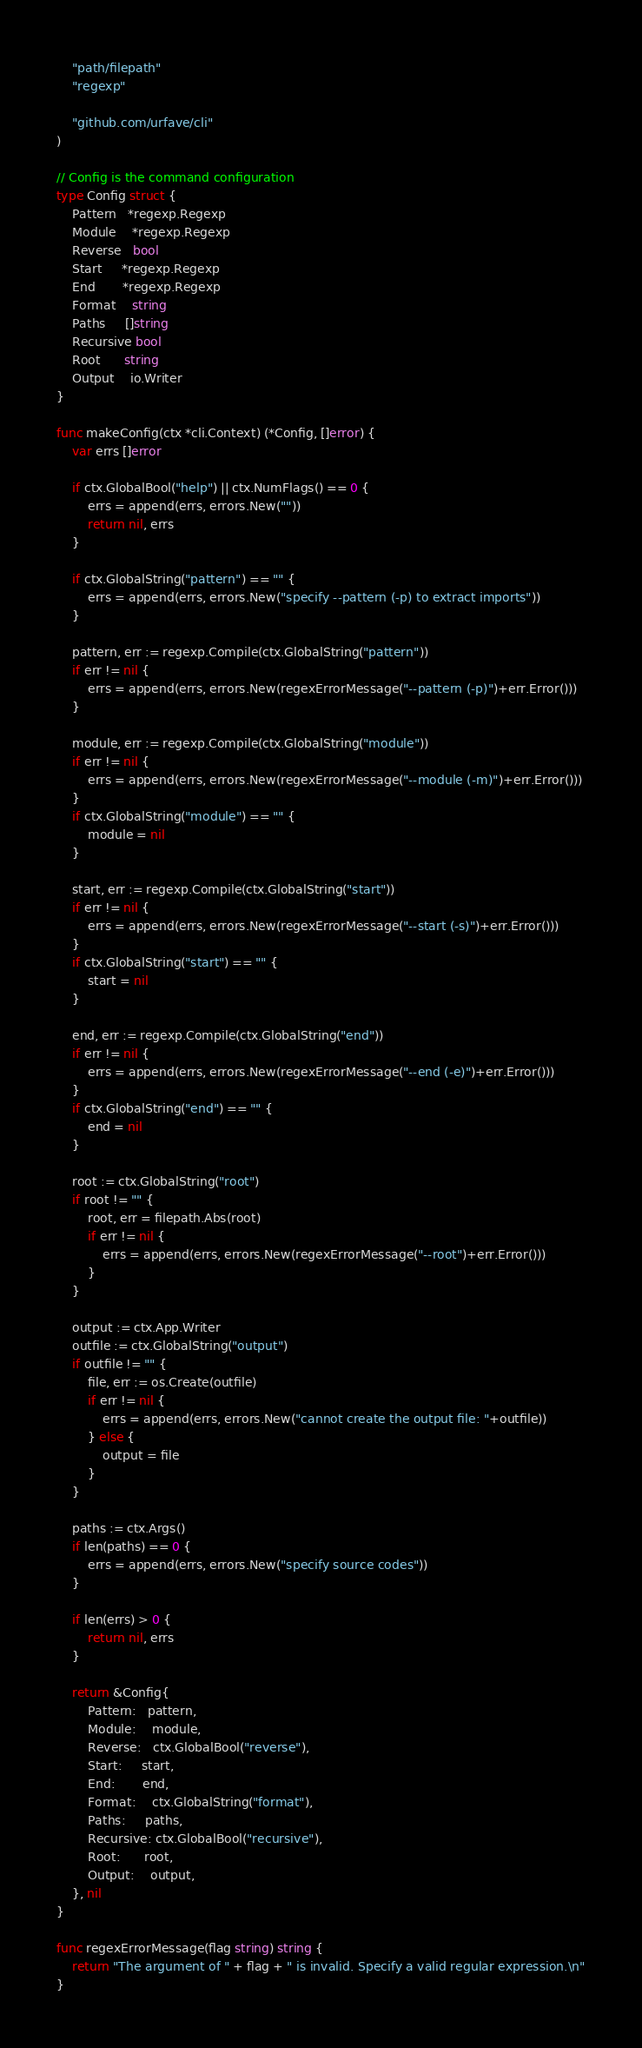<code> <loc_0><loc_0><loc_500><loc_500><_Go_>	"path/filepath"
	"regexp"

	"github.com/urfave/cli"
)

// Config is the command configuration
type Config struct {
	Pattern   *regexp.Regexp
	Module    *regexp.Regexp
	Reverse   bool
	Start     *regexp.Regexp
	End       *regexp.Regexp
	Format    string
	Paths     []string
	Recursive bool
	Root      string
	Output    io.Writer
}

func makeConfig(ctx *cli.Context) (*Config, []error) {
	var errs []error

	if ctx.GlobalBool("help") || ctx.NumFlags() == 0 {
		errs = append(errs, errors.New(""))
		return nil, errs
	}

	if ctx.GlobalString("pattern") == "" {
		errs = append(errs, errors.New("specify --pattern (-p) to extract imports"))
	}

	pattern, err := regexp.Compile(ctx.GlobalString("pattern"))
	if err != nil {
		errs = append(errs, errors.New(regexErrorMessage("--pattern (-p)")+err.Error()))
	}

	module, err := regexp.Compile(ctx.GlobalString("module"))
	if err != nil {
		errs = append(errs, errors.New(regexErrorMessage("--module (-m)")+err.Error()))
	}
	if ctx.GlobalString("module") == "" {
		module = nil
	}

	start, err := regexp.Compile(ctx.GlobalString("start"))
	if err != nil {
		errs = append(errs, errors.New(regexErrorMessage("--start (-s)")+err.Error()))
	}
	if ctx.GlobalString("start") == "" {
		start = nil
	}

	end, err := regexp.Compile(ctx.GlobalString("end"))
	if err != nil {
		errs = append(errs, errors.New(regexErrorMessage("--end (-e)")+err.Error()))
	}
	if ctx.GlobalString("end") == "" {
		end = nil
	}

	root := ctx.GlobalString("root")
	if root != "" {
		root, err = filepath.Abs(root)
		if err != nil {
			errs = append(errs, errors.New(regexErrorMessage("--root")+err.Error()))
		}
	}

	output := ctx.App.Writer
	outfile := ctx.GlobalString("output")
	if outfile != "" {
		file, err := os.Create(outfile)
		if err != nil {
			errs = append(errs, errors.New("cannot create the output file: "+outfile))
		} else {
			output = file
		}
	}

	paths := ctx.Args()
	if len(paths) == 0 {
		errs = append(errs, errors.New("specify source codes"))
	}

	if len(errs) > 0 {
		return nil, errs
	}

	return &Config{
		Pattern:   pattern,
		Module:    module,
		Reverse:   ctx.GlobalBool("reverse"),
		Start:     start,
		End:       end,
		Format:    ctx.GlobalString("format"),
		Paths:     paths,
		Recursive: ctx.GlobalBool("recursive"),
		Root:      root,
		Output:    output,
	}, nil
}

func regexErrorMessage(flag string) string {
	return "The argument of " + flag + " is invalid. Specify a valid regular expression.\n"
}
</code> 